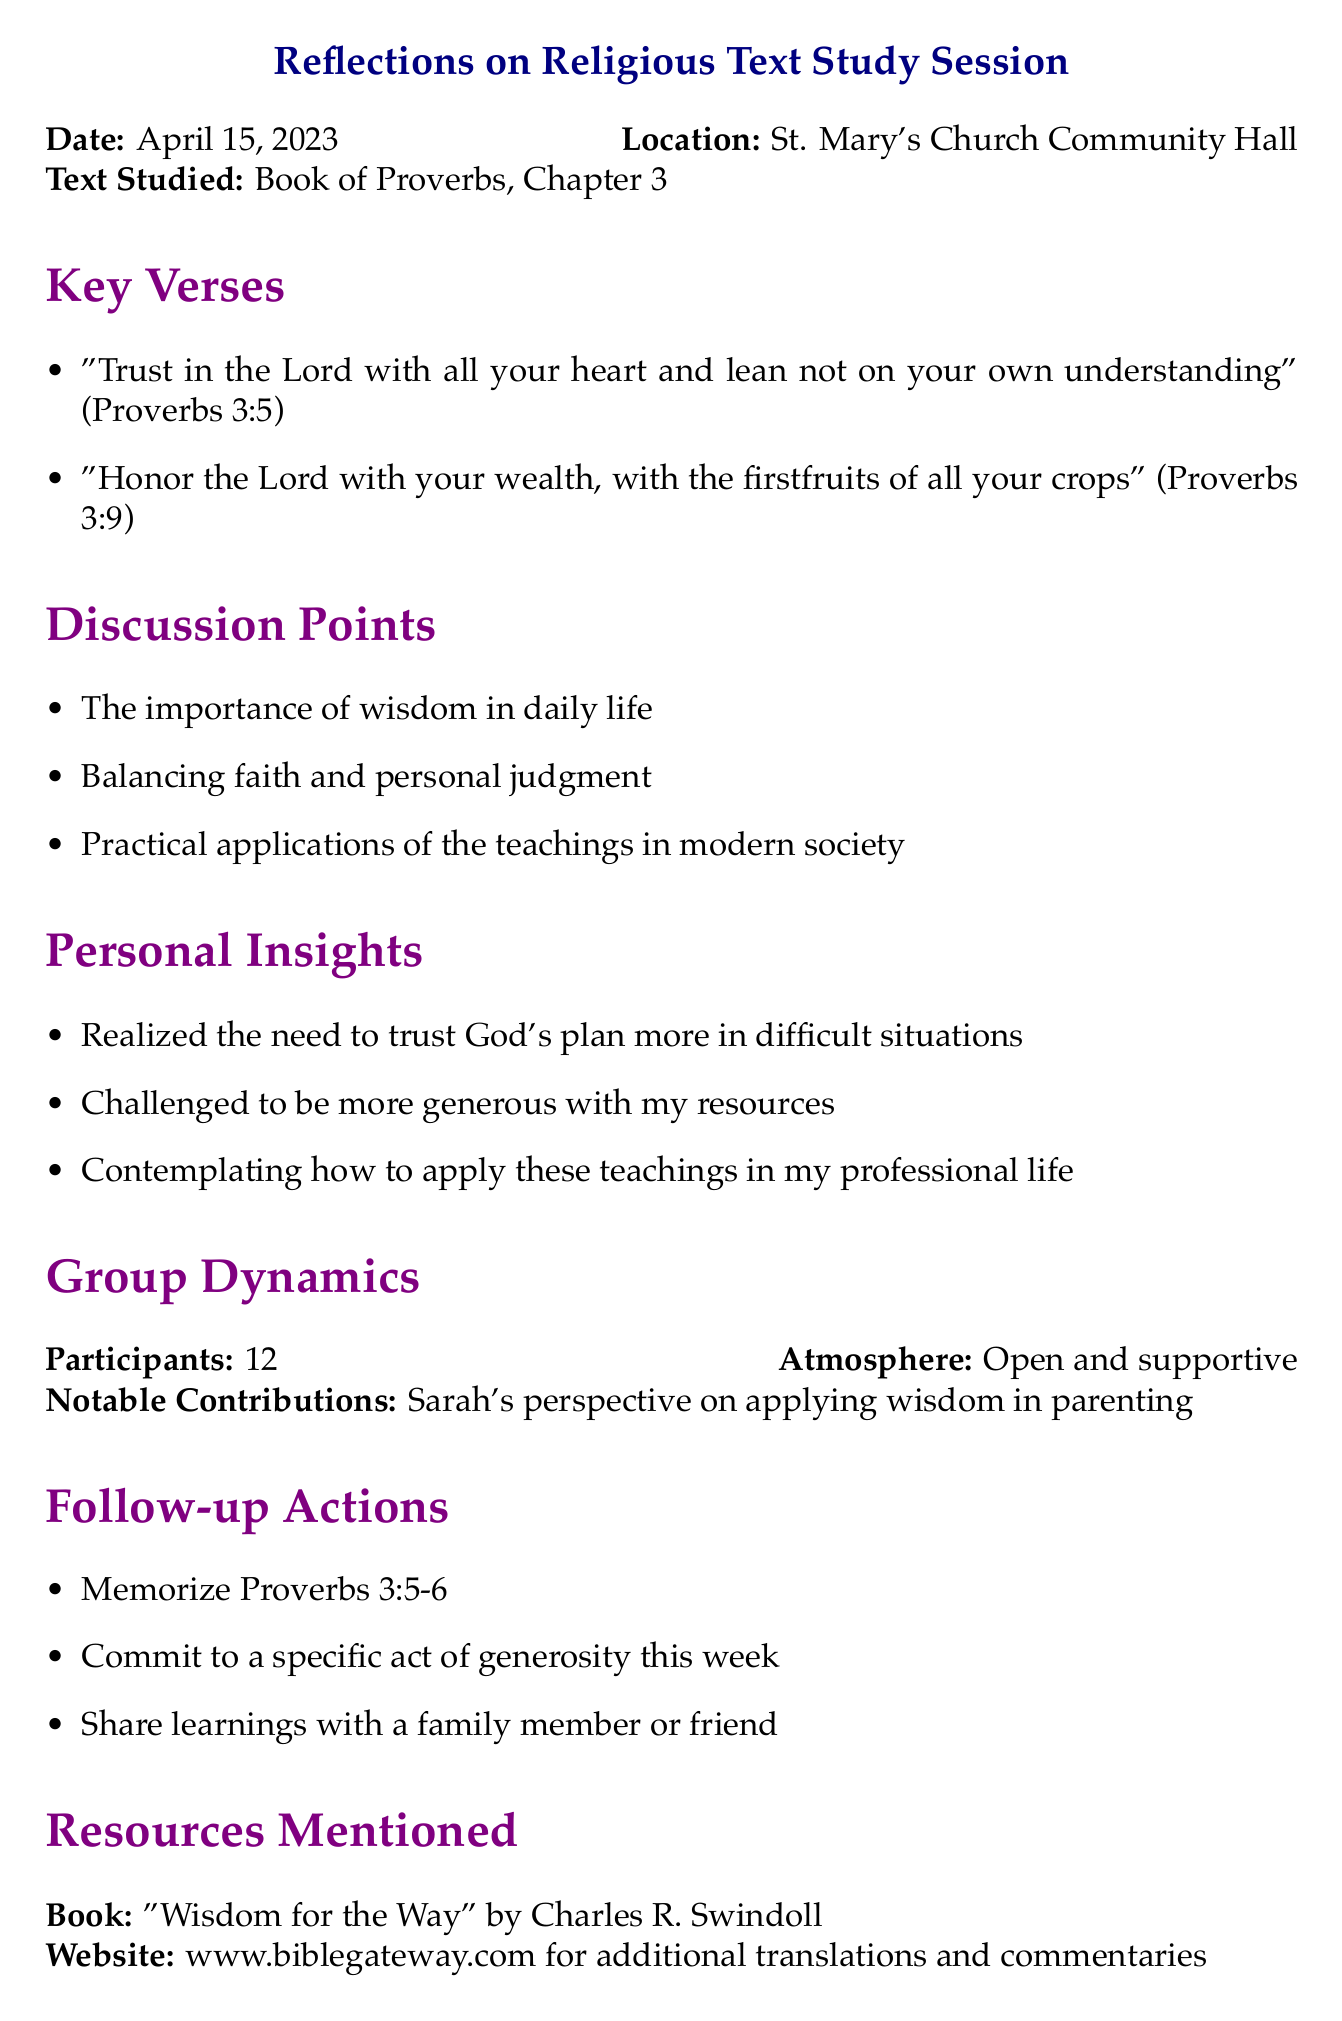What is the date of the study session? The date is explicitly mentioned in the document as April 15, 2023.
Answer: April 15, 2023 Where did the study session take place? The location is specified in the document, identifying it as St. Mary's Church Community Hall.
Answer: St. Mary's Church Community Hall How many participants were present in the session? The document states the number of participants as 12, which is clearly mentioned in the group dynamics section.
Answer: 12 What are the key verses studied? The document lists two specific verses from Proverbs 3 in the key verses section.
Answer: "Trust in the Lord with all your heart and lean not on your own understanding" and "Honor the Lord with your wealth, with the firstfruits of all your crops" What was one of the notable contributions during the discussion? The document highlights Sarah's perspective as a notable contribution in the group dynamics section.
Answer: Sarah's perspective on applying wisdom in parenting What follow-up action involves memorization? The document specifies that memorizing Proverbs 3:5-6 is one of the follow-up actions agreed upon.
Answer: Memorize Proverbs 3:5-6 What is the title of the book mentioned as a resource? The document identifies the referenced book as "Wisdom for the Way" by Charles R. Swindoll.
Answer: "Wisdom for the Way" by Charles R. Swindoll What is the atmosphere described during the session? The document describes the atmosphere as open and supportive in the group dynamics section.
Answer: Open and supportive 